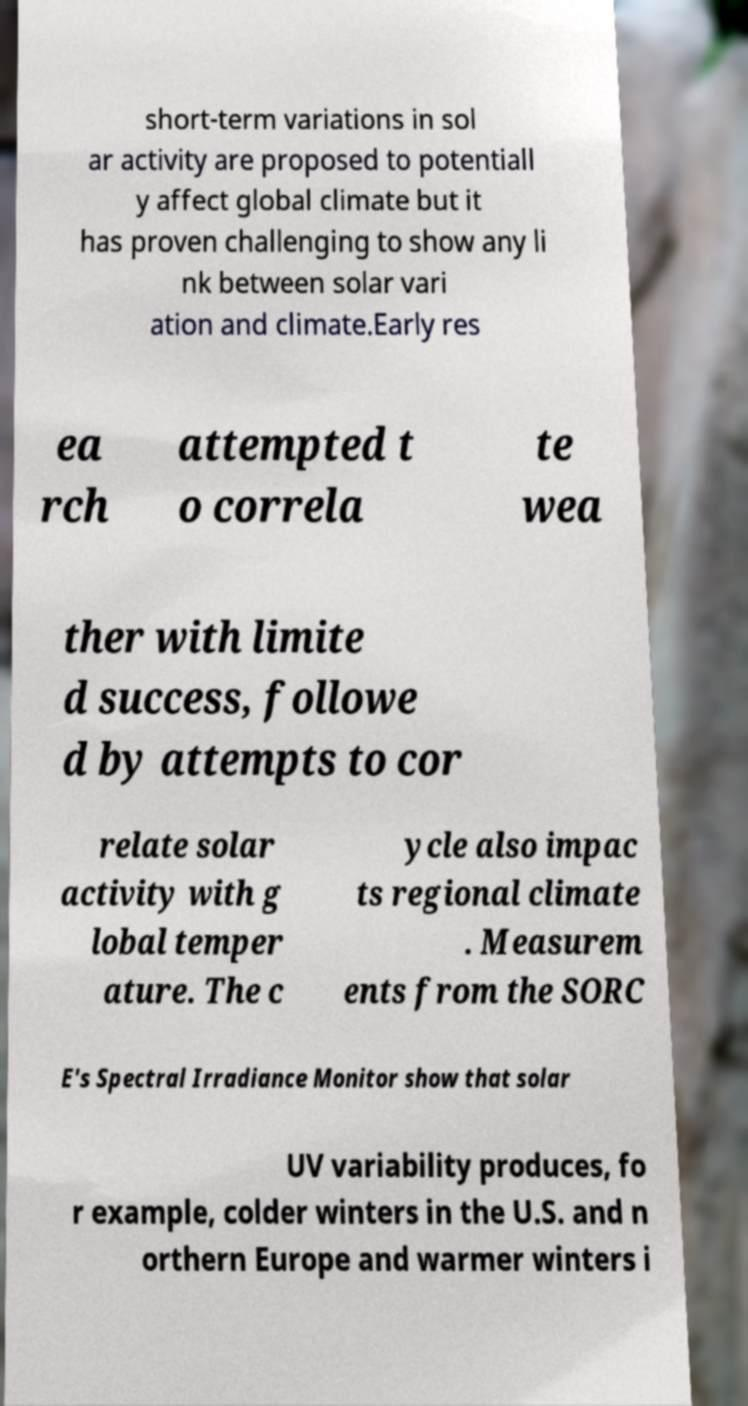There's text embedded in this image that I need extracted. Can you transcribe it verbatim? short-term variations in sol ar activity are proposed to potentiall y affect global climate but it has proven challenging to show any li nk between solar vari ation and climate.Early res ea rch attempted t o correla te wea ther with limite d success, followe d by attempts to cor relate solar activity with g lobal temper ature. The c ycle also impac ts regional climate . Measurem ents from the SORC E's Spectral Irradiance Monitor show that solar UV variability produces, fo r example, colder winters in the U.S. and n orthern Europe and warmer winters i 